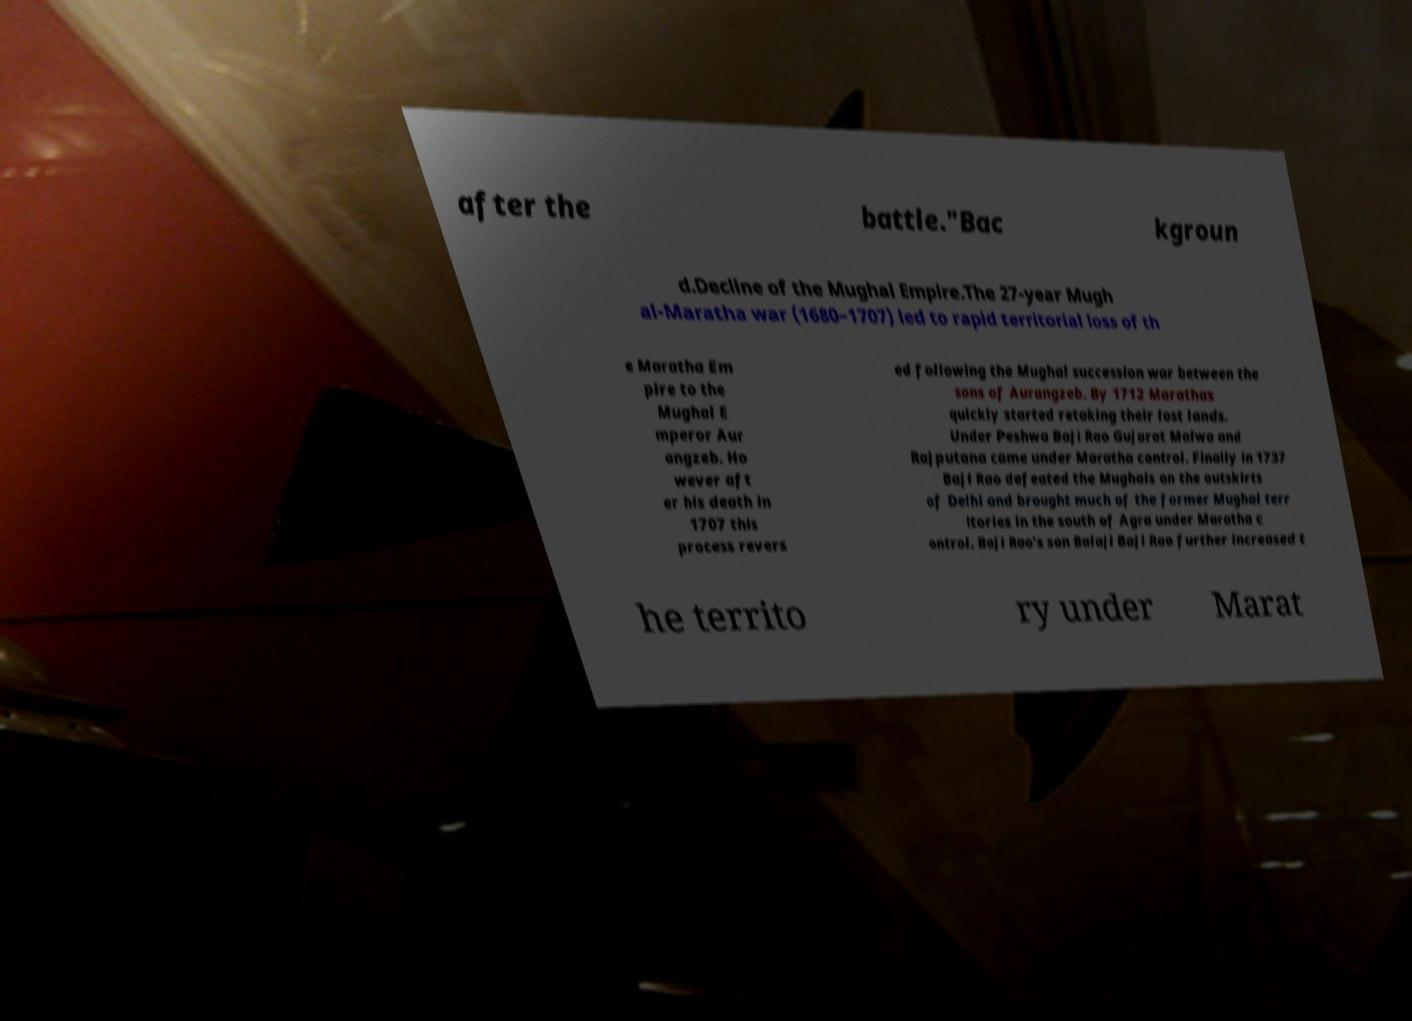Could you assist in decoding the text presented in this image and type it out clearly? after the battle."Bac kgroun d.Decline of the Mughal Empire.The 27-year Mugh al-Maratha war (1680–1707) led to rapid territorial loss of th e Maratha Em pire to the Mughal E mperor Aur angzeb. Ho wever aft er his death in 1707 this process revers ed following the Mughal succession war between the sons of Aurangzeb. By 1712 Marathas quickly started retaking their lost lands. Under Peshwa Baji Rao Gujarat Malwa and Rajputana came under Maratha control. Finally in 1737 Baji Rao defeated the Mughals on the outskirts of Delhi and brought much of the former Mughal terr itories in the south of Agra under Maratha c ontrol. Baji Rao's son Balaji Baji Rao further increased t he territo ry under Marat 